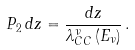<formula> <loc_0><loc_0><loc_500><loc_500>P _ { 2 } \, d z = \frac { d z } { \lambda _ { C C } ^ { \nu } \, ( E _ { \nu } ) } \, .</formula> 